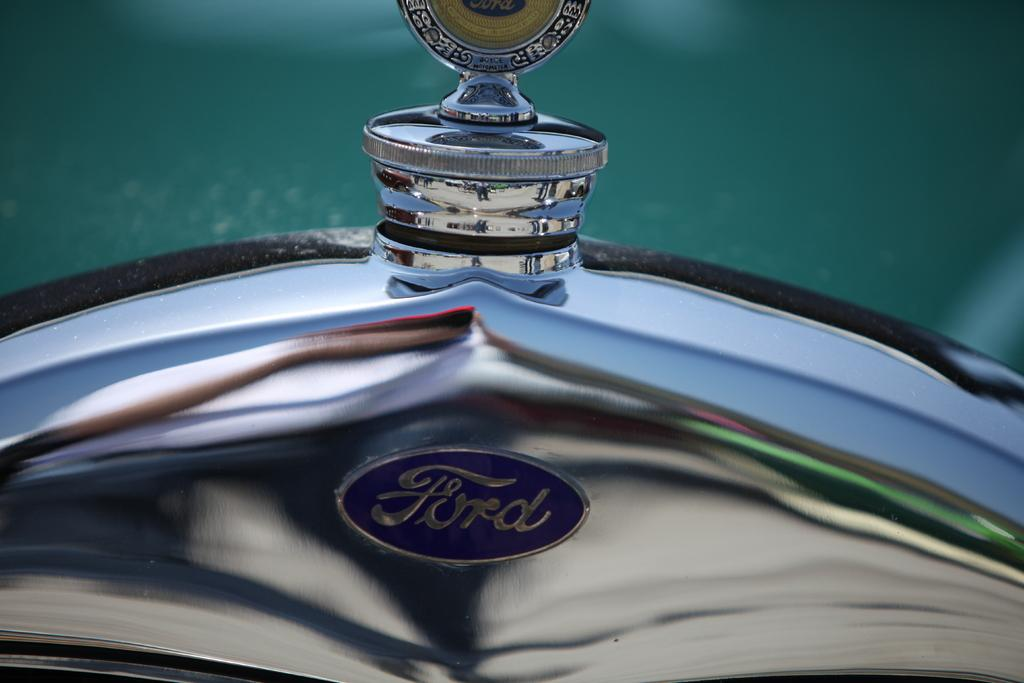What type of vehicle is partially visible in the image? The image shows a partial part of a vehicle from the Ford company. Can you describe any specific features of the vehicle? Unfortunately, only a partial part of the vehicle is visible, so it's difficult to describe specific features. What else can be seen in the image besides the vehicle? There is a reflection visible in the image. What type of apparel is the vehicle wearing in the image? Vehicles do not wear apparel, so this question cannot be answered. Can you describe the pipe that is connected to the vehicle in the image? There is no pipe connected to the vehicle in the image. 